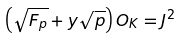Convert formula to latex. <formula><loc_0><loc_0><loc_500><loc_500>\left ( \sqrt { F _ { p } } + y \sqrt { p } \right ) O _ { K } = J ^ { 2 }</formula> 